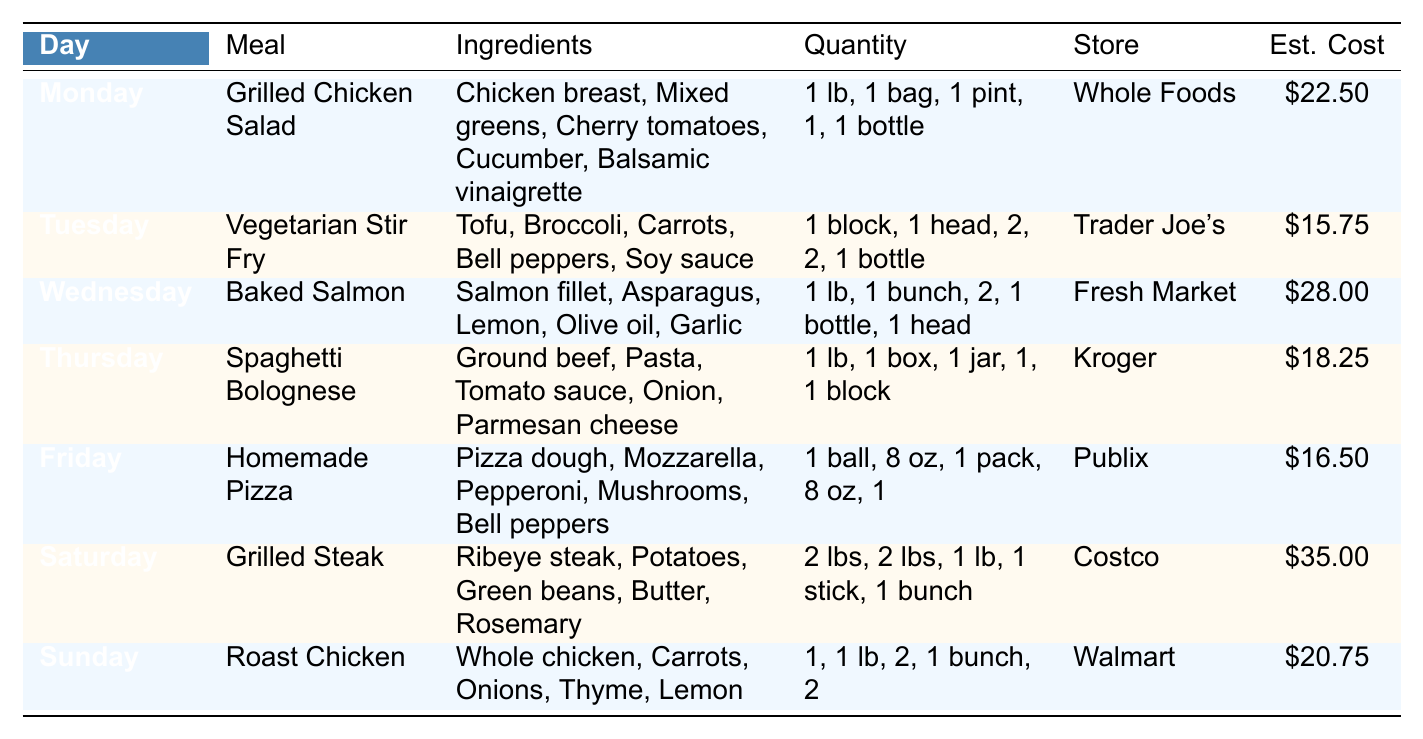What meal is planned for Thursday? The table lists the meal for Thursday as "Spaghetti Bolognese".
Answer: Spaghetti Bolognese Which store sells ingredients for the Homemade Pizza? According to the table, the ingredients for the Homemade Pizza are sold at Publix.
Answer: Publix How much is the estimated cost of the Baked Salmon meal? The estimated cost for the Baked Salmon meal is listed as $28.00 in the table.
Answer: $28.00 What ingredients are needed for the Vegetarian Stir Fry? The ingredients needed are Tofu, Broccoli, Carrots, Bell peppers, and Soy sauce, as mentioned in the table.
Answer: Tofu, Broccoli, Carrots, Bell peppers, Soy sauce On which day do you need to buy a ribeye steak? The table indicates that a ribeye steak is needed on Saturday for the Grilled Steak meal.
Answer: Saturday Which meal has the highest estimated cost? By reviewing the estimated costs, the Grilled Steak meal on Saturday has the highest cost at $35.00.
Answer: Grilled Steak How many vegetables are included in the Grilled Chicken Salad? The ingredients for the Grilled Chicken Salad consist of Mixed greens, Cherry tomatoes, Cucumber, which counts as three vegetables.
Answer: 3 What is the total estimated cost for meals on Monday and Tuesday? The individual costs for Monday and Tuesday are $22.50 and $15.75, respectively. Adding these gives $22.50 + $15.75 = $38.25 for both meals.
Answer: $38.25 Do any meals include lemon as an ingredient? Yes, both the Baked Salmon and Roast Chicken meals list lemon as an ingredient.
Answer: Yes How much more expensive is the Saturday meal compared to Tuesday’s meal? The estimated cost for Saturday's Grilled Steak is $35.00, and for Tuesday's Vegetarian Stir Fry, it is $15.75. The difference is $35.00 - $15.75 = $19.25.
Answer: $19.25 